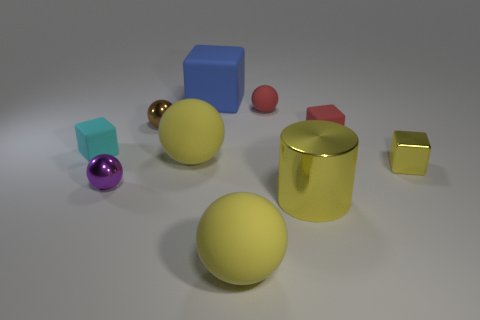Is the number of blocks left of the yellow metal cube greater than the number of tiny red cubes that are behind the big blue rubber thing?
Provide a short and direct response. Yes. There is a metal sphere that is behind the big yellow rubber thing that is behind the yellow thing that is to the right of the large cylinder; how big is it?
Provide a succinct answer. Small. Is the material of the large blue block the same as the large ball that is in front of the yellow metallic cube?
Offer a very short reply. Yes. Is the small purple object the same shape as the brown metal thing?
Your answer should be compact. Yes. What number of other objects are the same material as the cyan block?
Give a very brief answer. 5. What number of tiny yellow shiny objects have the same shape as the cyan thing?
Make the answer very short. 1. The cube that is to the left of the shiny cylinder and behind the tiny cyan matte block is what color?
Your answer should be compact. Blue. How many big red shiny spheres are there?
Make the answer very short. 0. Do the cyan block and the blue cube have the same size?
Provide a short and direct response. No. Are there any other tiny cylinders that have the same color as the metal cylinder?
Your response must be concise. No. 